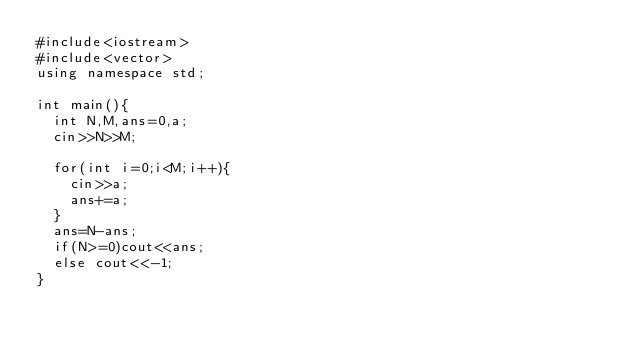<code> <loc_0><loc_0><loc_500><loc_500><_C++_>#include<iostream>
#include<vector>
using namespace std;

int main(){
  int N,M,ans=0,a;
  cin>>N>>M;
  
  for(int i=0;i<M;i++){
    cin>>a;
    ans+=a;
  }
  ans=N-ans;
  if(N>=0)cout<<ans;
  else cout<<-1;
}</code> 